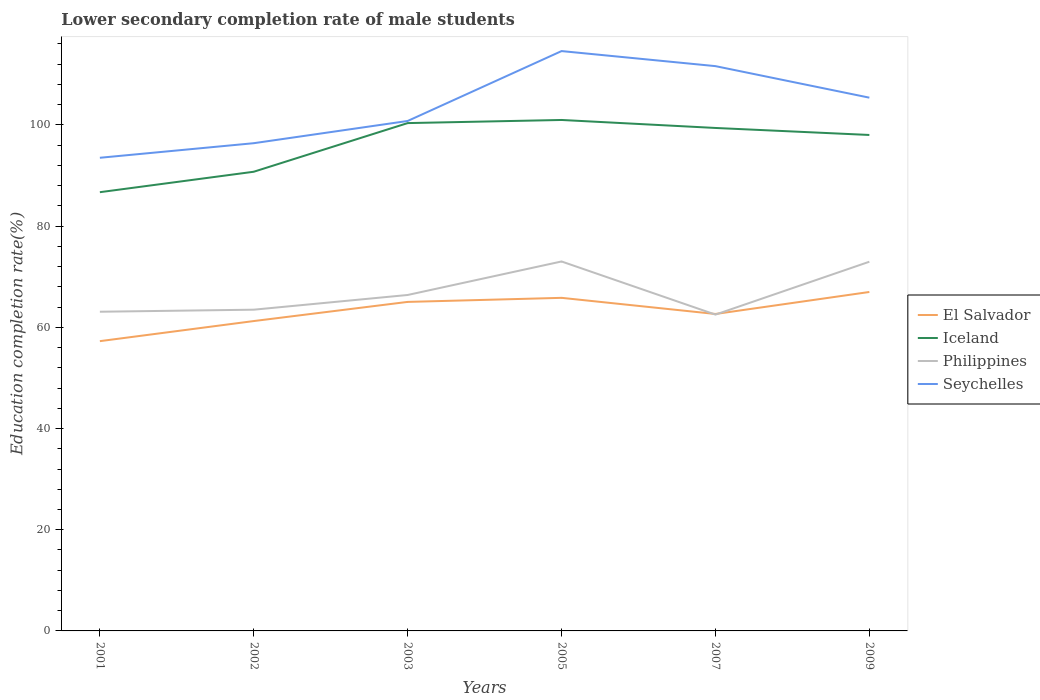How many different coloured lines are there?
Your response must be concise. 4. Does the line corresponding to El Salvador intersect with the line corresponding to Iceland?
Keep it short and to the point. No. Is the number of lines equal to the number of legend labels?
Your answer should be very brief. Yes. Across all years, what is the maximum lower secondary completion rate of male students in Philippines?
Your answer should be compact. 62.52. In which year was the lower secondary completion rate of male students in Philippines maximum?
Provide a succinct answer. 2007. What is the total lower secondary completion rate of male students in Seychelles in the graph?
Provide a short and direct response. -7.27. What is the difference between the highest and the second highest lower secondary completion rate of male students in Philippines?
Your response must be concise. 10.5. Does the graph contain any zero values?
Your response must be concise. No. Where does the legend appear in the graph?
Your response must be concise. Center right. How many legend labels are there?
Ensure brevity in your answer.  4. What is the title of the graph?
Give a very brief answer. Lower secondary completion rate of male students. What is the label or title of the X-axis?
Offer a terse response. Years. What is the label or title of the Y-axis?
Give a very brief answer. Education completion rate(%). What is the Education completion rate(%) in El Salvador in 2001?
Make the answer very short. 57.27. What is the Education completion rate(%) in Iceland in 2001?
Offer a terse response. 86.71. What is the Education completion rate(%) in Philippines in 2001?
Your response must be concise. 63.08. What is the Education completion rate(%) in Seychelles in 2001?
Ensure brevity in your answer.  93.51. What is the Education completion rate(%) of El Salvador in 2002?
Provide a short and direct response. 61.24. What is the Education completion rate(%) in Iceland in 2002?
Your answer should be compact. 90.75. What is the Education completion rate(%) in Philippines in 2002?
Ensure brevity in your answer.  63.49. What is the Education completion rate(%) of Seychelles in 2002?
Offer a terse response. 96.39. What is the Education completion rate(%) of El Salvador in 2003?
Provide a short and direct response. 65.03. What is the Education completion rate(%) in Iceland in 2003?
Give a very brief answer. 100.37. What is the Education completion rate(%) in Philippines in 2003?
Keep it short and to the point. 66.39. What is the Education completion rate(%) of Seychelles in 2003?
Your response must be concise. 100.78. What is the Education completion rate(%) of El Salvador in 2005?
Ensure brevity in your answer.  65.83. What is the Education completion rate(%) of Iceland in 2005?
Keep it short and to the point. 100.98. What is the Education completion rate(%) of Philippines in 2005?
Provide a succinct answer. 73.02. What is the Education completion rate(%) in Seychelles in 2005?
Make the answer very short. 114.6. What is the Education completion rate(%) in El Salvador in 2007?
Your answer should be compact. 62.64. What is the Education completion rate(%) of Iceland in 2007?
Provide a short and direct response. 99.4. What is the Education completion rate(%) in Philippines in 2007?
Offer a very short reply. 62.52. What is the Education completion rate(%) in Seychelles in 2007?
Your answer should be compact. 111.62. What is the Education completion rate(%) in El Salvador in 2009?
Your answer should be very brief. 66.99. What is the Education completion rate(%) in Iceland in 2009?
Your answer should be very brief. 98.02. What is the Education completion rate(%) of Philippines in 2009?
Offer a terse response. 72.97. What is the Education completion rate(%) in Seychelles in 2009?
Ensure brevity in your answer.  105.39. Across all years, what is the maximum Education completion rate(%) in El Salvador?
Your answer should be compact. 66.99. Across all years, what is the maximum Education completion rate(%) in Iceland?
Give a very brief answer. 100.98. Across all years, what is the maximum Education completion rate(%) of Philippines?
Your answer should be very brief. 73.02. Across all years, what is the maximum Education completion rate(%) in Seychelles?
Give a very brief answer. 114.6. Across all years, what is the minimum Education completion rate(%) of El Salvador?
Keep it short and to the point. 57.27. Across all years, what is the minimum Education completion rate(%) of Iceland?
Make the answer very short. 86.71. Across all years, what is the minimum Education completion rate(%) in Philippines?
Ensure brevity in your answer.  62.52. Across all years, what is the minimum Education completion rate(%) in Seychelles?
Provide a succinct answer. 93.51. What is the total Education completion rate(%) of El Salvador in the graph?
Provide a short and direct response. 378.99. What is the total Education completion rate(%) of Iceland in the graph?
Ensure brevity in your answer.  576.23. What is the total Education completion rate(%) in Philippines in the graph?
Give a very brief answer. 401.46. What is the total Education completion rate(%) in Seychelles in the graph?
Provide a succinct answer. 622.3. What is the difference between the Education completion rate(%) of El Salvador in 2001 and that in 2002?
Your answer should be very brief. -3.97. What is the difference between the Education completion rate(%) of Iceland in 2001 and that in 2002?
Ensure brevity in your answer.  -4.04. What is the difference between the Education completion rate(%) in Philippines in 2001 and that in 2002?
Provide a short and direct response. -0.4. What is the difference between the Education completion rate(%) in Seychelles in 2001 and that in 2002?
Your response must be concise. -2.88. What is the difference between the Education completion rate(%) in El Salvador in 2001 and that in 2003?
Provide a short and direct response. -7.76. What is the difference between the Education completion rate(%) of Iceland in 2001 and that in 2003?
Give a very brief answer. -13.66. What is the difference between the Education completion rate(%) in Philippines in 2001 and that in 2003?
Your response must be concise. -3.31. What is the difference between the Education completion rate(%) in Seychelles in 2001 and that in 2003?
Your response must be concise. -7.27. What is the difference between the Education completion rate(%) of El Salvador in 2001 and that in 2005?
Provide a succinct answer. -8.56. What is the difference between the Education completion rate(%) of Iceland in 2001 and that in 2005?
Your response must be concise. -14.27. What is the difference between the Education completion rate(%) of Philippines in 2001 and that in 2005?
Offer a very short reply. -9.93. What is the difference between the Education completion rate(%) of Seychelles in 2001 and that in 2005?
Make the answer very short. -21.09. What is the difference between the Education completion rate(%) of El Salvador in 2001 and that in 2007?
Ensure brevity in your answer.  -5.37. What is the difference between the Education completion rate(%) of Iceland in 2001 and that in 2007?
Offer a very short reply. -12.69. What is the difference between the Education completion rate(%) of Philippines in 2001 and that in 2007?
Your answer should be very brief. 0.57. What is the difference between the Education completion rate(%) in Seychelles in 2001 and that in 2007?
Your answer should be compact. -18.11. What is the difference between the Education completion rate(%) of El Salvador in 2001 and that in 2009?
Keep it short and to the point. -9.72. What is the difference between the Education completion rate(%) of Iceland in 2001 and that in 2009?
Your answer should be very brief. -11.31. What is the difference between the Education completion rate(%) in Philippines in 2001 and that in 2009?
Your response must be concise. -9.88. What is the difference between the Education completion rate(%) of Seychelles in 2001 and that in 2009?
Your answer should be compact. -11.88. What is the difference between the Education completion rate(%) in El Salvador in 2002 and that in 2003?
Your answer should be compact. -3.79. What is the difference between the Education completion rate(%) of Iceland in 2002 and that in 2003?
Provide a short and direct response. -9.62. What is the difference between the Education completion rate(%) of Philippines in 2002 and that in 2003?
Your response must be concise. -2.91. What is the difference between the Education completion rate(%) in Seychelles in 2002 and that in 2003?
Ensure brevity in your answer.  -4.39. What is the difference between the Education completion rate(%) of El Salvador in 2002 and that in 2005?
Your response must be concise. -4.59. What is the difference between the Education completion rate(%) of Iceland in 2002 and that in 2005?
Provide a succinct answer. -10.23. What is the difference between the Education completion rate(%) of Philippines in 2002 and that in 2005?
Keep it short and to the point. -9.53. What is the difference between the Education completion rate(%) in Seychelles in 2002 and that in 2005?
Offer a terse response. -18.21. What is the difference between the Education completion rate(%) in El Salvador in 2002 and that in 2007?
Provide a short and direct response. -1.4. What is the difference between the Education completion rate(%) in Iceland in 2002 and that in 2007?
Provide a short and direct response. -8.65. What is the difference between the Education completion rate(%) of Philippines in 2002 and that in 2007?
Your answer should be compact. 0.97. What is the difference between the Education completion rate(%) in Seychelles in 2002 and that in 2007?
Offer a very short reply. -15.23. What is the difference between the Education completion rate(%) of El Salvador in 2002 and that in 2009?
Offer a very short reply. -5.75. What is the difference between the Education completion rate(%) in Iceland in 2002 and that in 2009?
Your answer should be very brief. -7.27. What is the difference between the Education completion rate(%) of Philippines in 2002 and that in 2009?
Your answer should be compact. -9.48. What is the difference between the Education completion rate(%) of Seychelles in 2002 and that in 2009?
Offer a terse response. -9. What is the difference between the Education completion rate(%) of El Salvador in 2003 and that in 2005?
Provide a short and direct response. -0.8. What is the difference between the Education completion rate(%) of Iceland in 2003 and that in 2005?
Provide a succinct answer. -0.62. What is the difference between the Education completion rate(%) of Philippines in 2003 and that in 2005?
Ensure brevity in your answer.  -6.62. What is the difference between the Education completion rate(%) of Seychelles in 2003 and that in 2005?
Make the answer very short. -13.81. What is the difference between the Education completion rate(%) of El Salvador in 2003 and that in 2007?
Your answer should be compact. 2.39. What is the difference between the Education completion rate(%) of Iceland in 2003 and that in 2007?
Provide a succinct answer. 0.96. What is the difference between the Education completion rate(%) of Philippines in 2003 and that in 2007?
Provide a short and direct response. 3.88. What is the difference between the Education completion rate(%) in Seychelles in 2003 and that in 2007?
Provide a short and direct response. -10.84. What is the difference between the Education completion rate(%) of El Salvador in 2003 and that in 2009?
Offer a terse response. -1.96. What is the difference between the Education completion rate(%) in Iceland in 2003 and that in 2009?
Offer a very short reply. 2.35. What is the difference between the Education completion rate(%) of Philippines in 2003 and that in 2009?
Ensure brevity in your answer.  -6.57. What is the difference between the Education completion rate(%) of Seychelles in 2003 and that in 2009?
Provide a short and direct response. -4.61. What is the difference between the Education completion rate(%) of El Salvador in 2005 and that in 2007?
Your answer should be very brief. 3.19. What is the difference between the Education completion rate(%) of Iceland in 2005 and that in 2007?
Keep it short and to the point. 1.58. What is the difference between the Education completion rate(%) of Philippines in 2005 and that in 2007?
Offer a very short reply. 10.5. What is the difference between the Education completion rate(%) of Seychelles in 2005 and that in 2007?
Your response must be concise. 2.98. What is the difference between the Education completion rate(%) of El Salvador in 2005 and that in 2009?
Keep it short and to the point. -1.16. What is the difference between the Education completion rate(%) in Iceland in 2005 and that in 2009?
Keep it short and to the point. 2.97. What is the difference between the Education completion rate(%) in Philippines in 2005 and that in 2009?
Give a very brief answer. 0.05. What is the difference between the Education completion rate(%) of Seychelles in 2005 and that in 2009?
Your answer should be very brief. 9.21. What is the difference between the Education completion rate(%) in El Salvador in 2007 and that in 2009?
Offer a terse response. -4.35. What is the difference between the Education completion rate(%) of Iceland in 2007 and that in 2009?
Ensure brevity in your answer.  1.39. What is the difference between the Education completion rate(%) of Philippines in 2007 and that in 2009?
Offer a terse response. -10.45. What is the difference between the Education completion rate(%) of Seychelles in 2007 and that in 2009?
Provide a succinct answer. 6.23. What is the difference between the Education completion rate(%) of El Salvador in 2001 and the Education completion rate(%) of Iceland in 2002?
Your answer should be compact. -33.48. What is the difference between the Education completion rate(%) of El Salvador in 2001 and the Education completion rate(%) of Philippines in 2002?
Keep it short and to the point. -6.22. What is the difference between the Education completion rate(%) in El Salvador in 2001 and the Education completion rate(%) in Seychelles in 2002?
Make the answer very short. -39.12. What is the difference between the Education completion rate(%) in Iceland in 2001 and the Education completion rate(%) in Philippines in 2002?
Your answer should be compact. 23.22. What is the difference between the Education completion rate(%) of Iceland in 2001 and the Education completion rate(%) of Seychelles in 2002?
Offer a very short reply. -9.68. What is the difference between the Education completion rate(%) of Philippines in 2001 and the Education completion rate(%) of Seychelles in 2002?
Offer a very short reply. -33.31. What is the difference between the Education completion rate(%) in El Salvador in 2001 and the Education completion rate(%) in Iceland in 2003?
Offer a terse response. -43.1. What is the difference between the Education completion rate(%) in El Salvador in 2001 and the Education completion rate(%) in Philippines in 2003?
Your answer should be very brief. -9.13. What is the difference between the Education completion rate(%) in El Salvador in 2001 and the Education completion rate(%) in Seychelles in 2003?
Provide a short and direct response. -43.52. What is the difference between the Education completion rate(%) in Iceland in 2001 and the Education completion rate(%) in Philippines in 2003?
Keep it short and to the point. 20.32. What is the difference between the Education completion rate(%) of Iceland in 2001 and the Education completion rate(%) of Seychelles in 2003?
Offer a terse response. -14.07. What is the difference between the Education completion rate(%) of Philippines in 2001 and the Education completion rate(%) of Seychelles in 2003?
Keep it short and to the point. -37.7. What is the difference between the Education completion rate(%) in El Salvador in 2001 and the Education completion rate(%) in Iceland in 2005?
Your response must be concise. -43.71. What is the difference between the Education completion rate(%) of El Salvador in 2001 and the Education completion rate(%) of Philippines in 2005?
Ensure brevity in your answer.  -15.75. What is the difference between the Education completion rate(%) of El Salvador in 2001 and the Education completion rate(%) of Seychelles in 2005?
Your response must be concise. -57.33. What is the difference between the Education completion rate(%) of Iceland in 2001 and the Education completion rate(%) of Philippines in 2005?
Provide a short and direct response. 13.69. What is the difference between the Education completion rate(%) of Iceland in 2001 and the Education completion rate(%) of Seychelles in 2005?
Make the answer very short. -27.89. What is the difference between the Education completion rate(%) of Philippines in 2001 and the Education completion rate(%) of Seychelles in 2005?
Give a very brief answer. -51.51. What is the difference between the Education completion rate(%) in El Salvador in 2001 and the Education completion rate(%) in Iceland in 2007?
Make the answer very short. -42.13. What is the difference between the Education completion rate(%) in El Salvador in 2001 and the Education completion rate(%) in Philippines in 2007?
Keep it short and to the point. -5.25. What is the difference between the Education completion rate(%) in El Salvador in 2001 and the Education completion rate(%) in Seychelles in 2007?
Provide a succinct answer. -54.35. What is the difference between the Education completion rate(%) in Iceland in 2001 and the Education completion rate(%) in Philippines in 2007?
Ensure brevity in your answer.  24.19. What is the difference between the Education completion rate(%) of Iceland in 2001 and the Education completion rate(%) of Seychelles in 2007?
Your response must be concise. -24.91. What is the difference between the Education completion rate(%) of Philippines in 2001 and the Education completion rate(%) of Seychelles in 2007?
Provide a succinct answer. -48.54. What is the difference between the Education completion rate(%) in El Salvador in 2001 and the Education completion rate(%) in Iceland in 2009?
Offer a very short reply. -40.75. What is the difference between the Education completion rate(%) of El Salvador in 2001 and the Education completion rate(%) of Philippines in 2009?
Offer a very short reply. -15.7. What is the difference between the Education completion rate(%) of El Salvador in 2001 and the Education completion rate(%) of Seychelles in 2009?
Your answer should be very brief. -48.12. What is the difference between the Education completion rate(%) of Iceland in 2001 and the Education completion rate(%) of Philippines in 2009?
Your response must be concise. 13.74. What is the difference between the Education completion rate(%) of Iceland in 2001 and the Education completion rate(%) of Seychelles in 2009?
Make the answer very short. -18.68. What is the difference between the Education completion rate(%) of Philippines in 2001 and the Education completion rate(%) of Seychelles in 2009?
Provide a succinct answer. -42.31. What is the difference between the Education completion rate(%) of El Salvador in 2002 and the Education completion rate(%) of Iceland in 2003?
Your response must be concise. -39.13. What is the difference between the Education completion rate(%) of El Salvador in 2002 and the Education completion rate(%) of Philippines in 2003?
Your answer should be very brief. -5.15. What is the difference between the Education completion rate(%) of El Salvador in 2002 and the Education completion rate(%) of Seychelles in 2003?
Ensure brevity in your answer.  -39.55. What is the difference between the Education completion rate(%) of Iceland in 2002 and the Education completion rate(%) of Philippines in 2003?
Ensure brevity in your answer.  24.36. What is the difference between the Education completion rate(%) of Iceland in 2002 and the Education completion rate(%) of Seychelles in 2003?
Make the answer very short. -10.03. What is the difference between the Education completion rate(%) in Philippines in 2002 and the Education completion rate(%) in Seychelles in 2003?
Your answer should be very brief. -37.3. What is the difference between the Education completion rate(%) of El Salvador in 2002 and the Education completion rate(%) of Iceland in 2005?
Your response must be concise. -39.74. What is the difference between the Education completion rate(%) in El Salvador in 2002 and the Education completion rate(%) in Philippines in 2005?
Keep it short and to the point. -11.78. What is the difference between the Education completion rate(%) of El Salvador in 2002 and the Education completion rate(%) of Seychelles in 2005?
Your answer should be compact. -53.36. What is the difference between the Education completion rate(%) of Iceland in 2002 and the Education completion rate(%) of Philippines in 2005?
Make the answer very short. 17.73. What is the difference between the Education completion rate(%) of Iceland in 2002 and the Education completion rate(%) of Seychelles in 2005?
Make the answer very short. -23.85. What is the difference between the Education completion rate(%) in Philippines in 2002 and the Education completion rate(%) in Seychelles in 2005?
Ensure brevity in your answer.  -51.11. What is the difference between the Education completion rate(%) of El Salvador in 2002 and the Education completion rate(%) of Iceland in 2007?
Make the answer very short. -38.16. What is the difference between the Education completion rate(%) in El Salvador in 2002 and the Education completion rate(%) in Philippines in 2007?
Offer a very short reply. -1.28. What is the difference between the Education completion rate(%) in El Salvador in 2002 and the Education completion rate(%) in Seychelles in 2007?
Offer a terse response. -50.38. What is the difference between the Education completion rate(%) in Iceland in 2002 and the Education completion rate(%) in Philippines in 2007?
Your answer should be very brief. 28.24. What is the difference between the Education completion rate(%) in Iceland in 2002 and the Education completion rate(%) in Seychelles in 2007?
Provide a succinct answer. -20.87. What is the difference between the Education completion rate(%) in Philippines in 2002 and the Education completion rate(%) in Seychelles in 2007?
Provide a short and direct response. -48.13. What is the difference between the Education completion rate(%) in El Salvador in 2002 and the Education completion rate(%) in Iceland in 2009?
Provide a succinct answer. -36.78. What is the difference between the Education completion rate(%) in El Salvador in 2002 and the Education completion rate(%) in Philippines in 2009?
Provide a short and direct response. -11.73. What is the difference between the Education completion rate(%) of El Salvador in 2002 and the Education completion rate(%) of Seychelles in 2009?
Ensure brevity in your answer.  -44.15. What is the difference between the Education completion rate(%) of Iceland in 2002 and the Education completion rate(%) of Philippines in 2009?
Offer a very short reply. 17.78. What is the difference between the Education completion rate(%) of Iceland in 2002 and the Education completion rate(%) of Seychelles in 2009?
Give a very brief answer. -14.64. What is the difference between the Education completion rate(%) in Philippines in 2002 and the Education completion rate(%) in Seychelles in 2009?
Ensure brevity in your answer.  -41.9. What is the difference between the Education completion rate(%) in El Salvador in 2003 and the Education completion rate(%) in Iceland in 2005?
Offer a very short reply. -35.96. What is the difference between the Education completion rate(%) of El Salvador in 2003 and the Education completion rate(%) of Philippines in 2005?
Make the answer very short. -7.99. What is the difference between the Education completion rate(%) of El Salvador in 2003 and the Education completion rate(%) of Seychelles in 2005?
Keep it short and to the point. -49.57. What is the difference between the Education completion rate(%) of Iceland in 2003 and the Education completion rate(%) of Philippines in 2005?
Your answer should be compact. 27.35. What is the difference between the Education completion rate(%) of Iceland in 2003 and the Education completion rate(%) of Seychelles in 2005?
Give a very brief answer. -14.23. What is the difference between the Education completion rate(%) in Philippines in 2003 and the Education completion rate(%) in Seychelles in 2005?
Your answer should be very brief. -48.2. What is the difference between the Education completion rate(%) of El Salvador in 2003 and the Education completion rate(%) of Iceland in 2007?
Offer a very short reply. -34.38. What is the difference between the Education completion rate(%) of El Salvador in 2003 and the Education completion rate(%) of Philippines in 2007?
Offer a terse response. 2.51. What is the difference between the Education completion rate(%) in El Salvador in 2003 and the Education completion rate(%) in Seychelles in 2007?
Provide a succinct answer. -46.6. What is the difference between the Education completion rate(%) in Iceland in 2003 and the Education completion rate(%) in Philippines in 2007?
Ensure brevity in your answer.  37.85. What is the difference between the Education completion rate(%) of Iceland in 2003 and the Education completion rate(%) of Seychelles in 2007?
Provide a succinct answer. -11.26. What is the difference between the Education completion rate(%) in Philippines in 2003 and the Education completion rate(%) in Seychelles in 2007?
Offer a terse response. -45.23. What is the difference between the Education completion rate(%) of El Salvador in 2003 and the Education completion rate(%) of Iceland in 2009?
Make the answer very short. -32.99. What is the difference between the Education completion rate(%) in El Salvador in 2003 and the Education completion rate(%) in Philippines in 2009?
Your answer should be compact. -7.94. What is the difference between the Education completion rate(%) of El Salvador in 2003 and the Education completion rate(%) of Seychelles in 2009?
Provide a short and direct response. -40.37. What is the difference between the Education completion rate(%) in Iceland in 2003 and the Education completion rate(%) in Philippines in 2009?
Provide a succinct answer. 27.4. What is the difference between the Education completion rate(%) of Iceland in 2003 and the Education completion rate(%) of Seychelles in 2009?
Your answer should be very brief. -5.02. What is the difference between the Education completion rate(%) of Philippines in 2003 and the Education completion rate(%) of Seychelles in 2009?
Provide a succinct answer. -39. What is the difference between the Education completion rate(%) in El Salvador in 2005 and the Education completion rate(%) in Iceland in 2007?
Make the answer very short. -33.57. What is the difference between the Education completion rate(%) in El Salvador in 2005 and the Education completion rate(%) in Philippines in 2007?
Provide a short and direct response. 3.31. What is the difference between the Education completion rate(%) of El Salvador in 2005 and the Education completion rate(%) of Seychelles in 2007?
Ensure brevity in your answer.  -45.79. What is the difference between the Education completion rate(%) in Iceland in 2005 and the Education completion rate(%) in Philippines in 2007?
Provide a succinct answer. 38.47. What is the difference between the Education completion rate(%) in Iceland in 2005 and the Education completion rate(%) in Seychelles in 2007?
Offer a very short reply. -10.64. What is the difference between the Education completion rate(%) of Philippines in 2005 and the Education completion rate(%) of Seychelles in 2007?
Keep it short and to the point. -38.6. What is the difference between the Education completion rate(%) in El Salvador in 2005 and the Education completion rate(%) in Iceland in 2009?
Ensure brevity in your answer.  -32.19. What is the difference between the Education completion rate(%) in El Salvador in 2005 and the Education completion rate(%) in Philippines in 2009?
Provide a succinct answer. -7.14. What is the difference between the Education completion rate(%) of El Salvador in 2005 and the Education completion rate(%) of Seychelles in 2009?
Provide a succinct answer. -39.56. What is the difference between the Education completion rate(%) of Iceland in 2005 and the Education completion rate(%) of Philippines in 2009?
Offer a terse response. 28.02. What is the difference between the Education completion rate(%) in Iceland in 2005 and the Education completion rate(%) in Seychelles in 2009?
Make the answer very short. -4.41. What is the difference between the Education completion rate(%) in Philippines in 2005 and the Education completion rate(%) in Seychelles in 2009?
Your answer should be very brief. -32.37. What is the difference between the Education completion rate(%) of El Salvador in 2007 and the Education completion rate(%) of Iceland in 2009?
Provide a succinct answer. -35.38. What is the difference between the Education completion rate(%) of El Salvador in 2007 and the Education completion rate(%) of Philippines in 2009?
Your response must be concise. -10.33. What is the difference between the Education completion rate(%) in El Salvador in 2007 and the Education completion rate(%) in Seychelles in 2009?
Your answer should be very brief. -42.75. What is the difference between the Education completion rate(%) in Iceland in 2007 and the Education completion rate(%) in Philippines in 2009?
Provide a succinct answer. 26.44. What is the difference between the Education completion rate(%) in Iceland in 2007 and the Education completion rate(%) in Seychelles in 2009?
Your response must be concise. -5.99. What is the difference between the Education completion rate(%) in Philippines in 2007 and the Education completion rate(%) in Seychelles in 2009?
Provide a short and direct response. -42.88. What is the average Education completion rate(%) of El Salvador per year?
Provide a succinct answer. 63.16. What is the average Education completion rate(%) of Iceland per year?
Provide a short and direct response. 96.04. What is the average Education completion rate(%) in Philippines per year?
Offer a terse response. 66.91. What is the average Education completion rate(%) of Seychelles per year?
Your response must be concise. 103.72. In the year 2001, what is the difference between the Education completion rate(%) of El Salvador and Education completion rate(%) of Iceland?
Your response must be concise. -29.44. In the year 2001, what is the difference between the Education completion rate(%) of El Salvador and Education completion rate(%) of Philippines?
Offer a terse response. -5.82. In the year 2001, what is the difference between the Education completion rate(%) of El Salvador and Education completion rate(%) of Seychelles?
Your response must be concise. -36.24. In the year 2001, what is the difference between the Education completion rate(%) in Iceland and Education completion rate(%) in Philippines?
Keep it short and to the point. 23.63. In the year 2001, what is the difference between the Education completion rate(%) in Iceland and Education completion rate(%) in Seychelles?
Your answer should be very brief. -6.8. In the year 2001, what is the difference between the Education completion rate(%) of Philippines and Education completion rate(%) of Seychelles?
Your answer should be very brief. -30.43. In the year 2002, what is the difference between the Education completion rate(%) of El Salvador and Education completion rate(%) of Iceland?
Ensure brevity in your answer.  -29.51. In the year 2002, what is the difference between the Education completion rate(%) of El Salvador and Education completion rate(%) of Philippines?
Provide a short and direct response. -2.25. In the year 2002, what is the difference between the Education completion rate(%) in El Salvador and Education completion rate(%) in Seychelles?
Ensure brevity in your answer.  -35.15. In the year 2002, what is the difference between the Education completion rate(%) in Iceland and Education completion rate(%) in Philippines?
Ensure brevity in your answer.  27.26. In the year 2002, what is the difference between the Education completion rate(%) in Iceland and Education completion rate(%) in Seychelles?
Offer a terse response. -5.64. In the year 2002, what is the difference between the Education completion rate(%) of Philippines and Education completion rate(%) of Seychelles?
Your answer should be compact. -32.91. In the year 2003, what is the difference between the Education completion rate(%) of El Salvador and Education completion rate(%) of Iceland?
Your response must be concise. -35.34. In the year 2003, what is the difference between the Education completion rate(%) of El Salvador and Education completion rate(%) of Philippines?
Your answer should be very brief. -1.37. In the year 2003, what is the difference between the Education completion rate(%) in El Salvador and Education completion rate(%) in Seychelles?
Give a very brief answer. -35.76. In the year 2003, what is the difference between the Education completion rate(%) in Iceland and Education completion rate(%) in Philippines?
Your answer should be compact. 33.97. In the year 2003, what is the difference between the Education completion rate(%) in Iceland and Education completion rate(%) in Seychelles?
Provide a short and direct response. -0.42. In the year 2003, what is the difference between the Education completion rate(%) of Philippines and Education completion rate(%) of Seychelles?
Offer a terse response. -34.39. In the year 2005, what is the difference between the Education completion rate(%) of El Salvador and Education completion rate(%) of Iceland?
Your answer should be very brief. -35.15. In the year 2005, what is the difference between the Education completion rate(%) in El Salvador and Education completion rate(%) in Philippines?
Keep it short and to the point. -7.19. In the year 2005, what is the difference between the Education completion rate(%) in El Salvador and Education completion rate(%) in Seychelles?
Your answer should be compact. -48.77. In the year 2005, what is the difference between the Education completion rate(%) in Iceland and Education completion rate(%) in Philippines?
Provide a short and direct response. 27.97. In the year 2005, what is the difference between the Education completion rate(%) in Iceland and Education completion rate(%) in Seychelles?
Give a very brief answer. -13.61. In the year 2005, what is the difference between the Education completion rate(%) of Philippines and Education completion rate(%) of Seychelles?
Your answer should be very brief. -41.58. In the year 2007, what is the difference between the Education completion rate(%) of El Salvador and Education completion rate(%) of Iceland?
Keep it short and to the point. -36.76. In the year 2007, what is the difference between the Education completion rate(%) in El Salvador and Education completion rate(%) in Philippines?
Offer a terse response. 0.12. In the year 2007, what is the difference between the Education completion rate(%) of El Salvador and Education completion rate(%) of Seychelles?
Your response must be concise. -48.98. In the year 2007, what is the difference between the Education completion rate(%) in Iceland and Education completion rate(%) in Philippines?
Provide a short and direct response. 36.89. In the year 2007, what is the difference between the Education completion rate(%) in Iceland and Education completion rate(%) in Seychelles?
Ensure brevity in your answer.  -12.22. In the year 2007, what is the difference between the Education completion rate(%) of Philippines and Education completion rate(%) of Seychelles?
Ensure brevity in your answer.  -49.11. In the year 2009, what is the difference between the Education completion rate(%) of El Salvador and Education completion rate(%) of Iceland?
Provide a short and direct response. -31.03. In the year 2009, what is the difference between the Education completion rate(%) of El Salvador and Education completion rate(%) of Philippines?
Provide a short and direct response. -5.98. In the year 2009, what is the difference between the Education completion rate(%) of El Salvador and Education completion rate(%) of Seychelles?
Offer a very short reply. -38.4. In the year 2009, what is the difference between the Education completion rate(%) of Iceland and Education completion rate(%) of Philippines?
Your answer should be compact. 25.05. In the year 2009, what is the difference between the Education completion rate(%) in Iceland and Education completion rate(%) in Seychelles?
Your response must be concise. -7.37. In the year 2009, what is the difference between the Education completion rate(%) in Philippines and Education completion rate(%) in Seychelles?
Provide a short and direct response. -32.42. What is the ratio of the Education completion rate(%) of El Salvador in 2001 to that in 2002?
Make the answer very short. 0.94. What is the ratio of the Education completion rate(%) of Iceland in 2001 to that in 2002?
Your response must be concise. 0.96. What is the ratio of the Education completion rate(%) of Seychelles in 2001 to that in 2002?
Make the answer very short. 0.97. What is the ratio of the Education completion rate(%) of El Salvador in 2001 to that in 2003?
Make the answer very short. 0.88. What is the ratio of the Education completion rate(%) in Iceland in 2001 to that in 2003?
Your response must be concise. 0.86. What is the ratio of the Education completion rate(%) in Philippines in 2001 to that in 2003?
Make the answer very short. 0.95. What is the ratio of the Education completion rate(%) of Seychelles in 2001 to that in 2003?
Make the answer very short. 0.93. What is the ratio of the Education completion rate(%) in El Salvador in 2001 to that in 2005?
Your answer should be very brief. 0.87. What is the ratio of the Education completion rate(%) in Iceland in 2001 to that in 2005?
Provide a short and direct response. 0.86. What is the ratio of the Education completion rate(%) in Philippines in 2001 to that in 2005?
Your answer should be very brief. 0.86. What is the ratio of the Education completion rate(%) in Seychelles in 2001 to that in 2005?
Make the answer very short. 0.82. What is the ratio of the Education completion rate(%) of El Salvador in 2001 to that in 2007?
Offer a terse response. 0.91. What is the ratio of the Education completion rate(%) in Iceland in 2001 to that in 2007?
Make the answer very short. 0.87. What is the ratio of the Education completion rate(%) of Philippines in 2001 to that in 2007?
Make the answer very short. 1.01. What is the ratio of the Education completion rate(%) of Seychelles in 2001 to that in 2007?
Provide a succinct answer. 0.84. What is the ratio of the Education completion rate(%) of El Salvador in 2001 to that in 2009?
Provide a short and direct response. 0.85. What is the ratio of the Education completion rate(%) in Iceland in 2001 to that in 2009?
Your response must be concise. 0.88. What is the ratio of the Education completion rate(%) in Philippines in 2001 to that in 2009?
Keep it short and to the point. 0.86. What is the ratio of the Education completion rate(%) of Seychelles in 2001 to that in 2009?
Provide a succinct answer. 0.89. What is the ratio of the Education completion rate(%) in El Salvador in 2002 to that in 2003?
Offer a terse response. 0.94. What is the ratio of the Education completion rate(%) in Iceland in 2002 to that in 2003?
Keep it short and to the point. 0.9. What is the ratio of the Education completion rate(%) of Philippines in 2002 to that in 2003?
Make the answer very short. 0.96. What is the ratio of the Education completion rate(%) in Seychelles in 2002 to that in 2003?
Your answer should be compact. 0.96. What is the ratio of the Education completion rate(%) in El Salvador in 2002 to that in 2005?
Provide a short and direct response. 0.93. What is the ratio of the Education completion rate(%) in Iceland in 2002 to that in 2005?
Provide a short and direct response. 0.9. What is the ratio of the Education completion rate(%) of Philippines in 2002 to that in 2005?
Your answer should be very brief. 0.87. What is the ratio of the Education completion rate(%) of Seychelles in 2002 to that in 2005?
Provide a short and direct response. 0.84. What is the ratio of the Education completion rate(%) of El Salvador in 2002 to that in 2007?
Give a very brief answer. 0.98. What is the ratio of the Education completion rate(%) in Philippines in 2002 to that in 2007?
Your response must be concise. 1.02. What is the ratio of the Education completion rate(%) of Seychelles in 2002 to that in 2007?
Offer a very short reply. 0.86. What is the ratio of the Education completion rate(%) in El Salvador in 2002 to that in 2009?
Your answer should be very brief. 0.91. What is the ratio of the Education completion rate(%) in Iceland in 2002 to that in 2009?
Provide a succinct answer. 0.93. What is the ratio of the Education completion rate(%) in Philippines in 2002 to that in 2009?
Offer a very short reply. 0.87. What is the ratio of the Education completion rate(%) of Seychelles in 2002 to that in 2009?
Ensure brevity in your answer.  0.91. What is the ratio of the Education completion rate(%) of Philippines in 2003 to that in 2005?
Your answer should be compact. 0.91. What is the ratio of the Education completion rate(%) of Seychelles in 2003 to that in 2005?
Ensure brevity in your answer.  0.88. What is the ratio of the Education completion rate(%) in El Salvador in 2003 to that in 2007?
Provide a short and direct response. 1.04. What is the ratio of the Education completion rate(%) of Iceland in 2003 to that in 2007?
Ensure brevity in your answer.  1.01. What is the ratio of the Education completion rate(%) of Philippines in 2003 to that in 2007?
Make the answer very short. 1.06. What is the ratio of the Education completion rate(%) in Seychelles in 2003 to that in 2007?
Give a very brief answer. 0.9. What is the ratio of the Education completion rate(%) in El Salvador in 2003 to that in 2009?
Keep it short and to the point. 0.97. What is the ratio of the Education completion rate(%) of Philippines in 2003 to that in 2009?
Provide a succinct answer. 0.91. What is the ratio of the Education completion rate(%) of Seychelles in 2003 to that in 2009?
Keep it short and to the point. 0.96. What is the ratio of the Education completion rate(%) in El Salvador in 2005 to that in 2007?
Offer a very short reply. 1.05. What is the ratio of the Education completion rate(%) of Iceland in 2005 to that in 2007?
Your answer should be very brief. 1.02. What is the ratio of the Education completion rate(%) of Philippines in 2005 to that in 2007?
Ensure brevity in your answer.  1.17. What is the ratio of the Education completion rate(%) in Seychelles in 2005 to that in 2007?
Your answer should be very brief. 1.03. What is the ratio of the Education completion rate(%) of El Salvador in 2005 to that in 2009?
Ensure brevity in your answer.  0.98. What is the ratio of the Education completion rate(%) in Iceland in 2005 to that in 2009?
Offer a terse response. 1.03. What is the ratio of the Education completion rate(%) of Philippines in 2005 to that in 2009?
Offer a terse response. 1. What is the ratio of the Education completion rate(%) in Seychelles in 2005 to that in 2009?
Offer a terse response. 1.09. What is the ratio of the Education completion rate(%) in El Salvador in 2007 to that in 2009?
Your response must be concise. 0.94. What is the ratio of the Education completion rate(%) in Iceland in 2007 to that in 2009?
Offer a very short reply. 1.01. What is the ratio of the Education completion rate(%) in Philippines in 2007 to that in 2009?
Give a very brief answer. 0.86. What is the ratio of the Education completion rate(%) in Seychelles in 2007 to that in 2009?
Your answer should be very brief. 1.06. What is the difference between the highest and the second highest Education completion rate(%) of El Salvador?
Offer a terse response. 1.16. What is the difference between the highest and the second highest Education completion rate(%) of Iceland?
Provide a short and direct response. 0.62. What is the difference between the highest and the second highest Education completion rate(%) of Philippines?
Your answer should be very brief. 0.05. What is the difference between the highest and the second highest Education completion rate(%) of Seychelles?
Make the answer very short. 2.98. What is the difference between the highest and the lowest Education completion rate(%) of El Salvador?
Your response must be concise. 9.72. What is the difference between the highest and the lowest Education completion rate(%) of Iceland?
Provide a short and direct response. 14.27. What is the difference between the highest and the lowest Education completion rate(%) in Philippines?
Give a very brief answer. 10.5. What is the difference between the highest and the lowest Education completion rate(%) in Seychelles?
Offer a terse response. 21.09. 